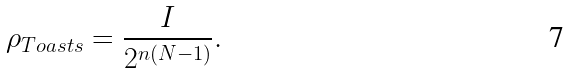<formula> <loc_0><loc_0><loc_500><loc_500>\rho _ { T o a s t s } = \frac { I } { 2 ^ { n ( N - 1 ) } } .</formula> 